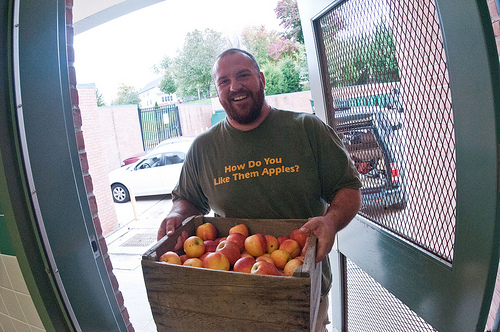<image>
Can you confirm if the fruit is in the box? Yes. The fruit is contained within or inside the box, showing a containment relationship. Is the man above the apples? No. The man is not positioned above the apples. The vertical arrangement shows a different relationship. 